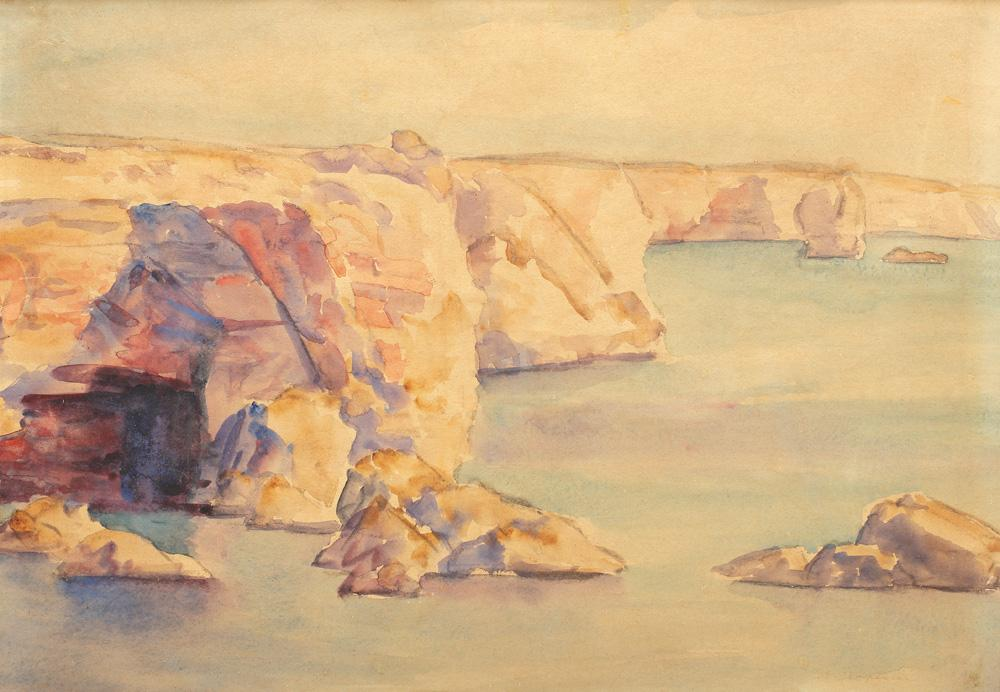Could you discuss the emotional impact or mood this painting might evoke in an observer? The painting emanates a peaceful and contemplative mood, likely evoking feelings of calmness and reflection in viewers. The soft interplay of light and color, alongside the sweeping, open views of the coast, invites the viewer to ponder the natural world's quiet beauty and the serene vastness of the sea. It might also stir a sense of nostalgia or solitude, characteristic of expansive landscapes depicted in such gentle and warm tones. 